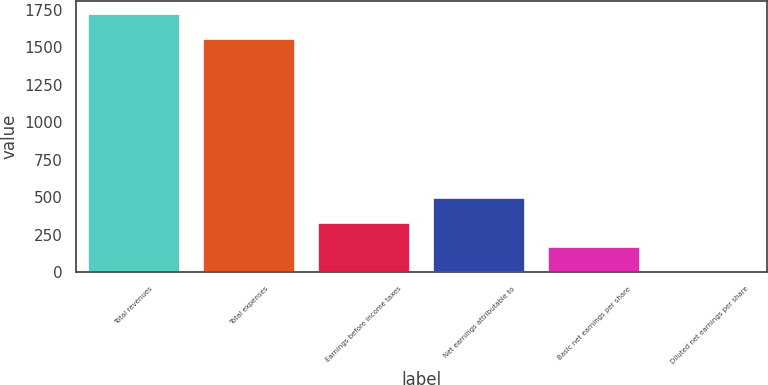Convert chart to OTSL. <chart><loc_0><loc_0><loc_500><loc_500><bar_chart><fcel>Total revenues<fcel>Total expenses<fcel>Earnings before income taxes<fcel>Net earnings attributable to<fcel>Basic net earnings per share<fcel>Diluted net earnings per share<nl><fcel>1722.78<fcel>1556.8<fcel>332.58<fcel>498.56<fcel>166.6<fcel>0.62<nl></chart> 